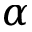Convert formula to latex. <formula><loc_0><loc_0><loc_500><loc_500>\alpha</formula> 